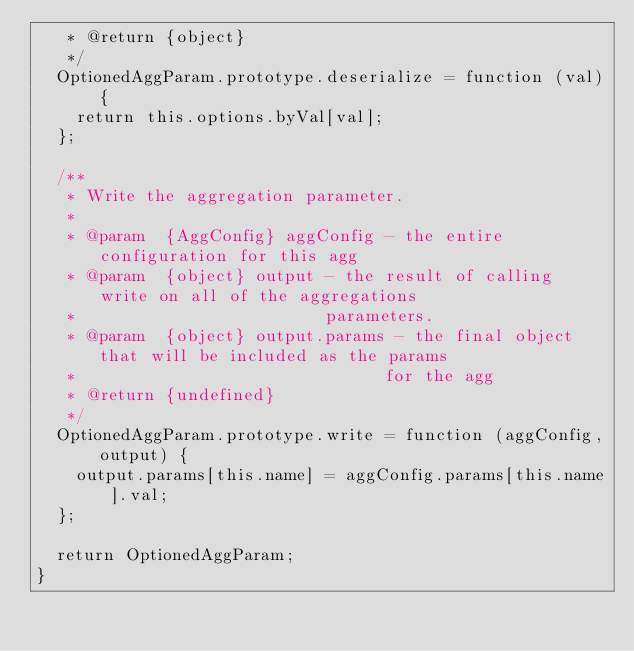Convert code to text. <code><loc_0><loc_0><loc_500><loc_500><_JavaScript_>   * @return {object}
   */
  OptionedAggParam.prototype.deserialize = function (val) {
    return this.options.byVal[val];
  };

  /**
   * Write the aggregation parameter.
   *
   * @param  {AggConfig} aggConfig - the entire configuration for this agg
   * @param  {object} output - the result of calling write on all of the aggregations
   *                         parameters.
   * @param  {object} output.params - the final object that will be included as the params
   *                               for the agg
   * @return {undefined}
   */
  OptionedAggParam.prototype.write = function (aggConfig, output) {
    output.params[this.name] = aggConfig.params[this.name].val;
  };

  return OptionedAggParam;
}
</code> 